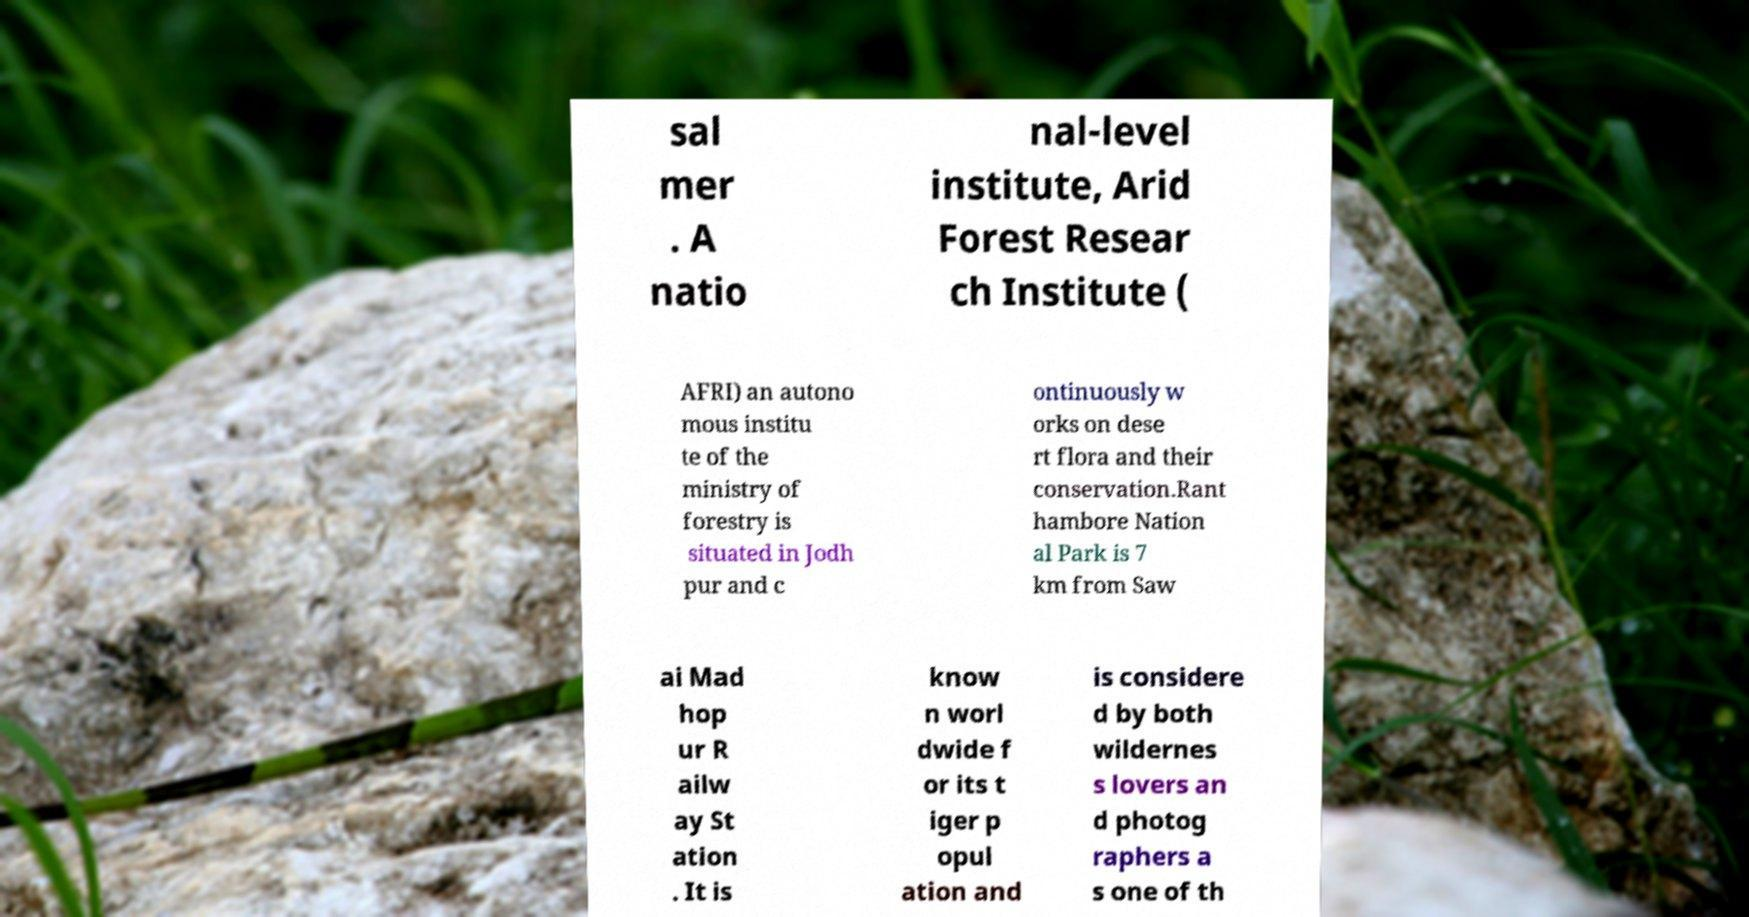I need the written content from this picture converted into text. Can you do that? sal mer . A natio nal-level institute, Arid Forest Resear ch Institute ( AFRI) an autono mous institu te of the ministry of forestry is situated in Jodh pur and c ontinuously w orks on dese rt flora and their conservation.Rant hambore Nation al Park is 7 km from Saw ai Mad hop ur R ailw ay St ation . It is know n worl dwide f or its t iger p opul ation and is considere d by both wildernes s lovers an d photog raphers a s one of th 